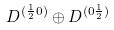Convert formula to latex. <formula><loc_0><loc_0><loc_500><loc_500>D ^ { ( \frac { 1 } { 2 } 0 ) } \oplus D ^ { ( 0 \frac { 1 } { 2 } ) }</formula> 